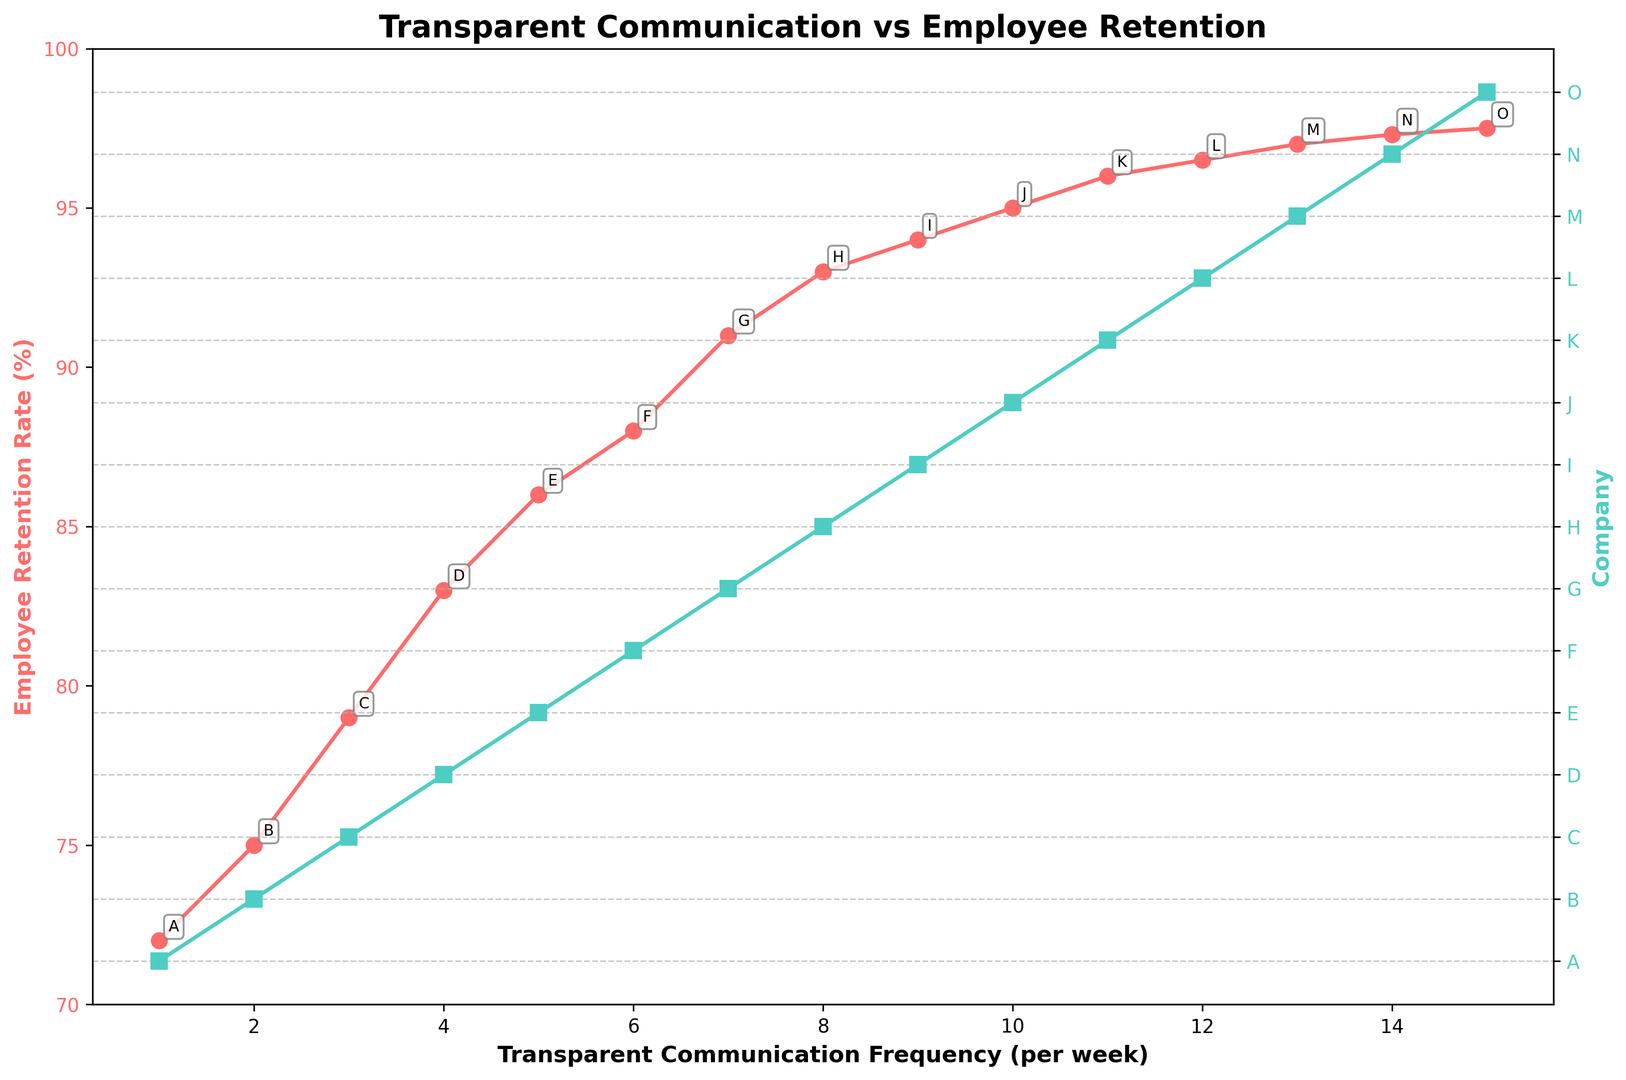What is the employee retention rate when the transparent communication frequency is 8 per week? The employee retention rate can be directly read from the y-axis corresponding to the x-value of 8 for transparent communication frequency. In the figure, this value is 93%.
Answer: 93% Compare the employee retention rates for companies with transparent communication frequencies of 3 and 12 per week. To find the employee retention rates, locate the two points on the plot. For a frequency of 3, the retention rate is 79%. For a frequency of 12, it is 96.5%. By comparing, 96.5% is higher than 79%.
Answer: 96.5% is higher than 79% What is the overall trend between transparent communication frequency and employee retention rate? Observe the plotted line and note the direction and slope. As the transparent communication frequency increases, the employee retention rate appears to increase as well.
Answer: Positive correlation What is the average retention rate for companies with transparent communication frequencies of 1, 5, 10, and 15 per week? Find the retention rates corresponding to the frequencies in the plot: 72%, 86%, 95%, and 97.5%, respectively. Calculate the average as (72 + 86 + 95 + 97.5) / 4.
Answer: 87.625% Which company shows the highest employee retention rate and what is the corresponding transparent communication frequency? Locate the highest point on the plot and read off the company label plus the x-value. The highest retention rate is 97.5%, which corresponds to a frequency of 15 per week by Company O.
Answer: Company O, 15 per week How many companies have an employee retention rate of 90% or higher? Identify the points on the plot where the retention rate is 90% or above. These occur at communication frequencies of 7, 8, 9, 10, 11, 12, 13, 14, and 15, covering nine points.
Answer: 9 companies What is the difference in employee retention rates between companies with the lowest and highest transparent communication frequencies? The lowest frequency is 1 with a retention rate of 72%. The highest is 15 with a retention rate of 97.5%. The difference is 97.5% - 72% = 25.5%.
Answer: 25.5% At which transparent communication frequency does the employee retention rate first exceed 90%? Locate where the retention rate curves upwards to exceed 90%. This first occurs at a communication frequency of 7 per week.
Answer: 7 Which company has a transparent communication frequency of 10 times per week and what is the corresponding employee retention rate? Identify the x-value of 10 on the plot and read its corresponding company and retention rate. This is Company J with a retention rate of 95%.
Answer: Company J, 95% What is the retention rate range between the company with the median transparent communication frequency and the company with the maximum frequency? Identify the median and maximum frequencies, which are 8 and 15 respectively. Their corresponding retention rates are 93% and 97.5%. So, 97.5% - 93% = 4.5%.
Answer: 4.5% 